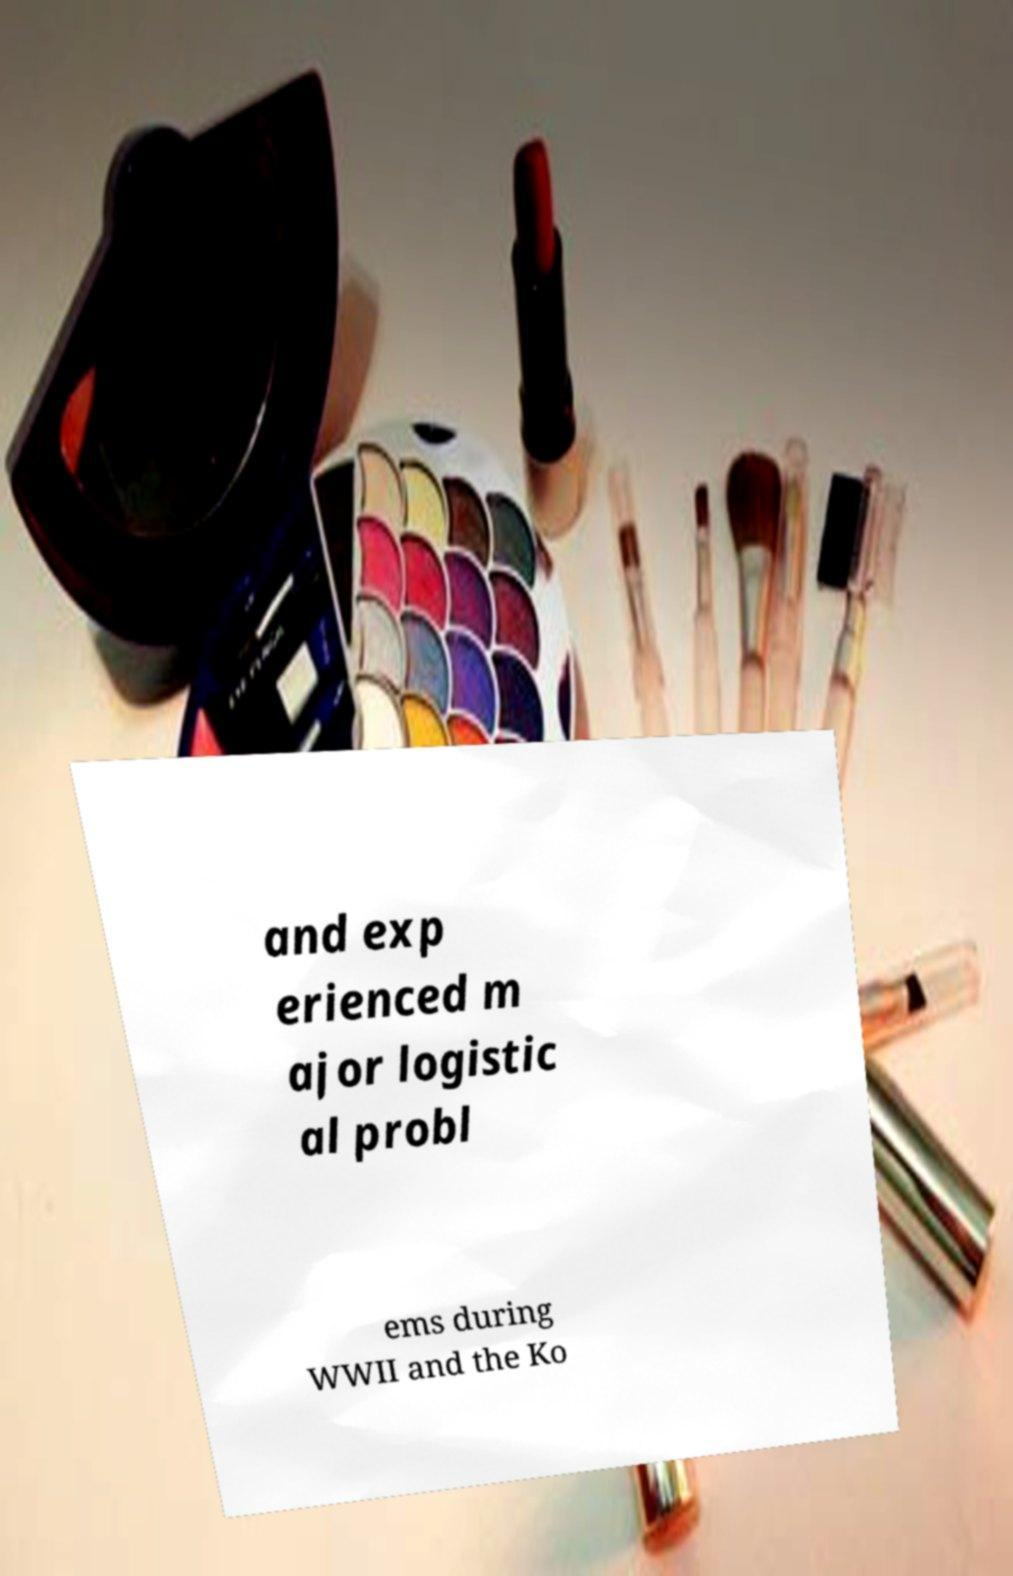Could you assist in decoding the text presented in this image and type it out clearly? and exp erienced m ajor logistic al probl ems during WWII and the Ko 